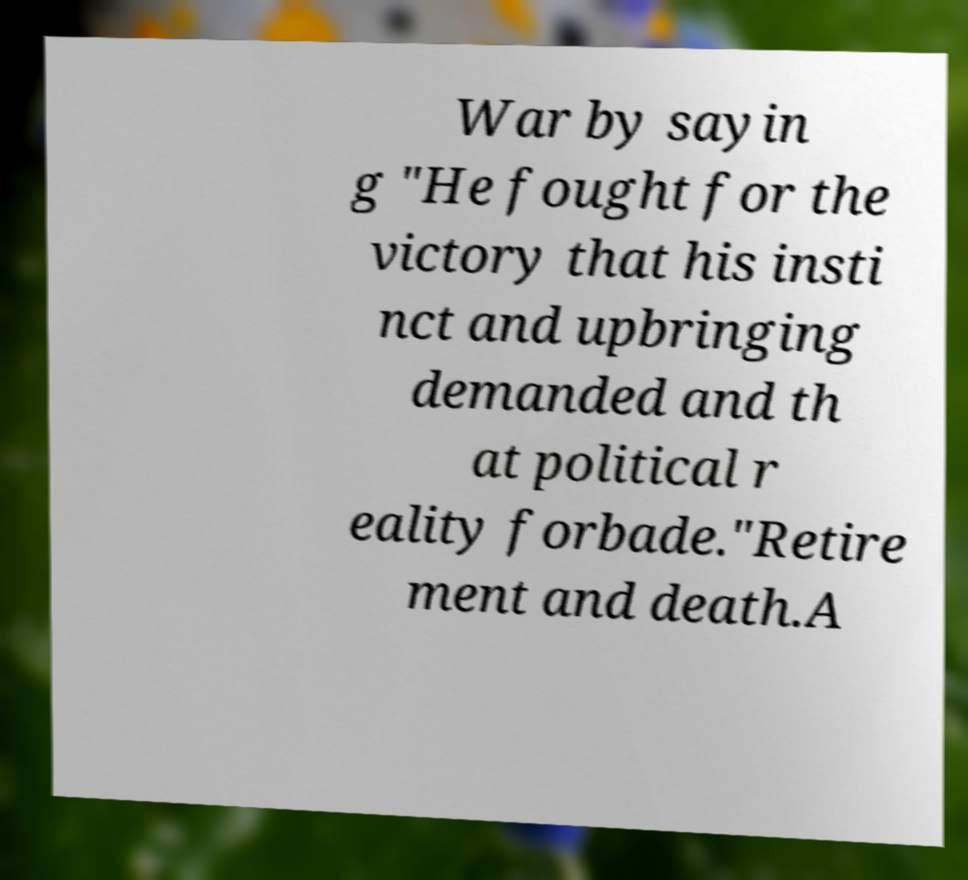For documentation purposes, I need the text within this image transcribed. Could you provide that? War by sayin g "He fought for the victory that his insti nct and upbringing demanded and th at political r eality forbade."Retire ment and death.A 